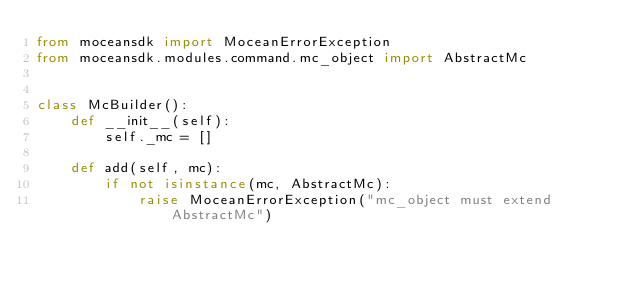Convert code to text. <code><loc_0><loc_0><loc_500><loc_500><_Python_>from moceansdk import MoceanErrorException
from moceansdk.modules.command.mc_object import AbstractMc


class McBuilder():
    def __init__(self):
        self._mc = []

    def add(self, mc):
        if not isinstance(mc, AbstractMc):
            raise MoceanErrorException("mc_object must extend AbstractMc")</code> 